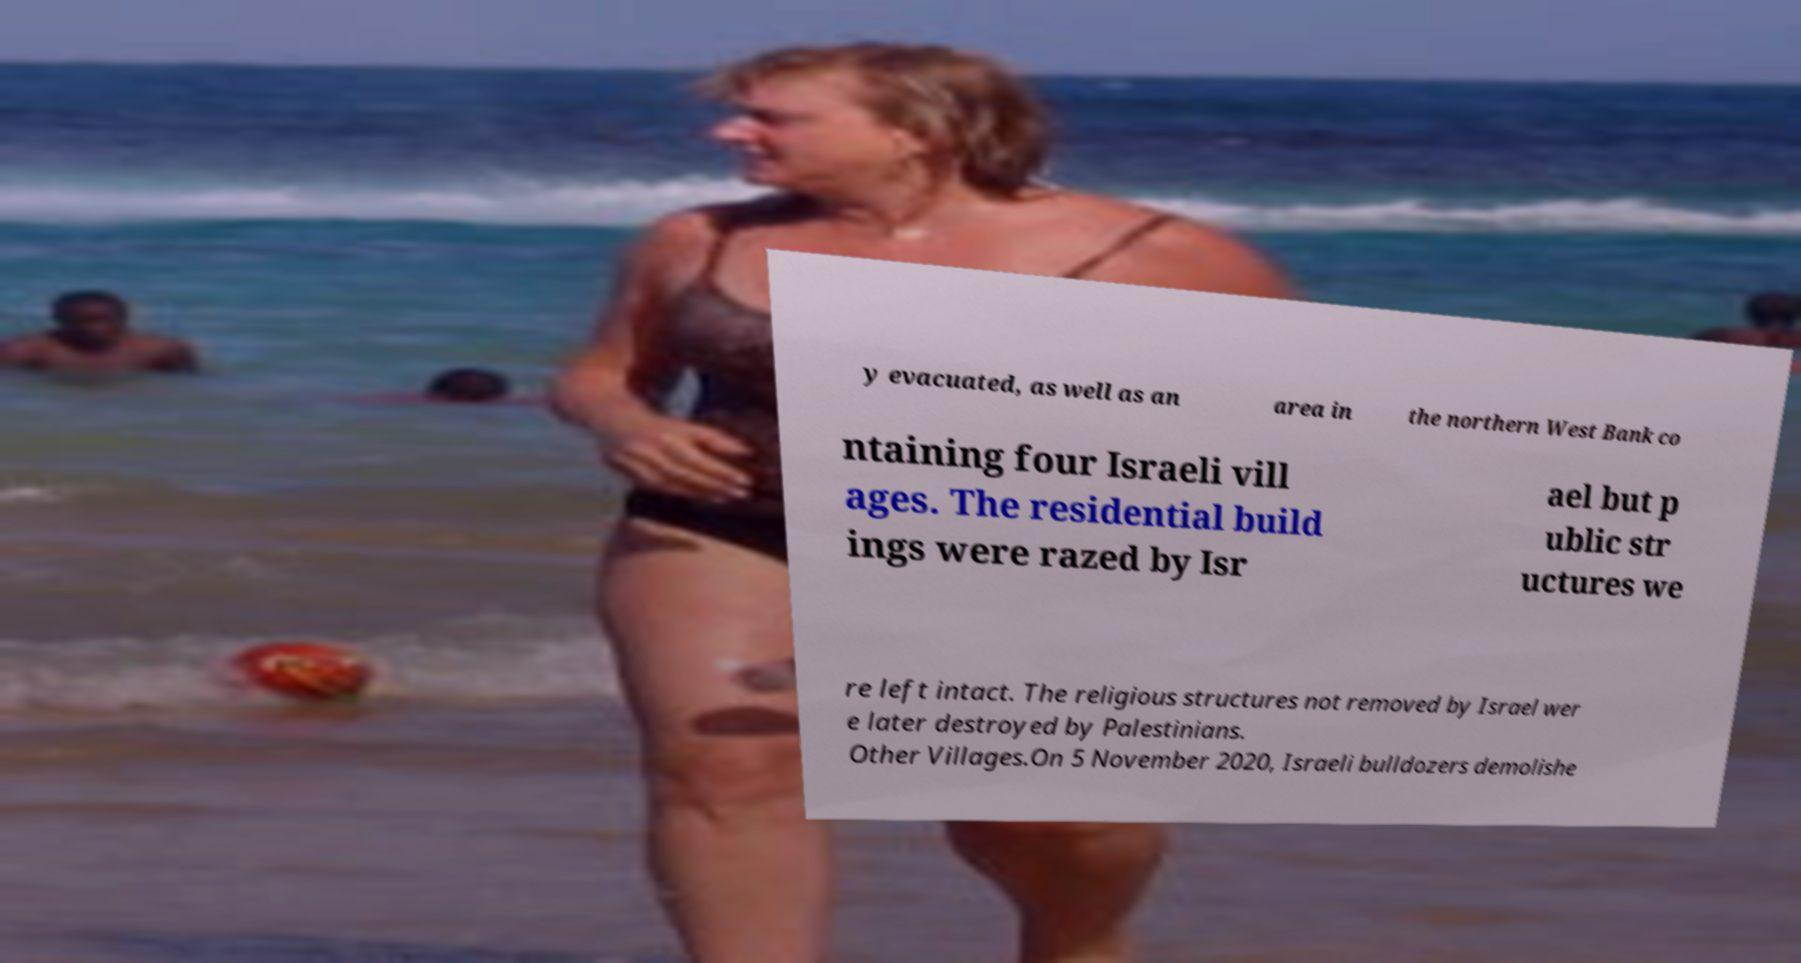There's text embedded in this image that I need extracted. Can you transcribe it verbatim? y evacuated, as well as an area in the northern West Bank co ntaining four Israeli vill ages. The residential build ings were razed by Isr ael but p ublic str uctures we re left intact. The religious structures not removed by Israel wer e later destroyed by Palestinians. Other Villages.On 5 November 2020, Israeli bulldozers demolishe 